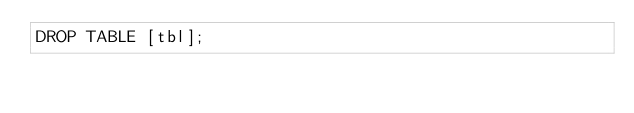Convert code to text. <code><loc_0><loc_0><loc_500><loc_500><_SQL_>DROP TABLE [tbl];

</code> 